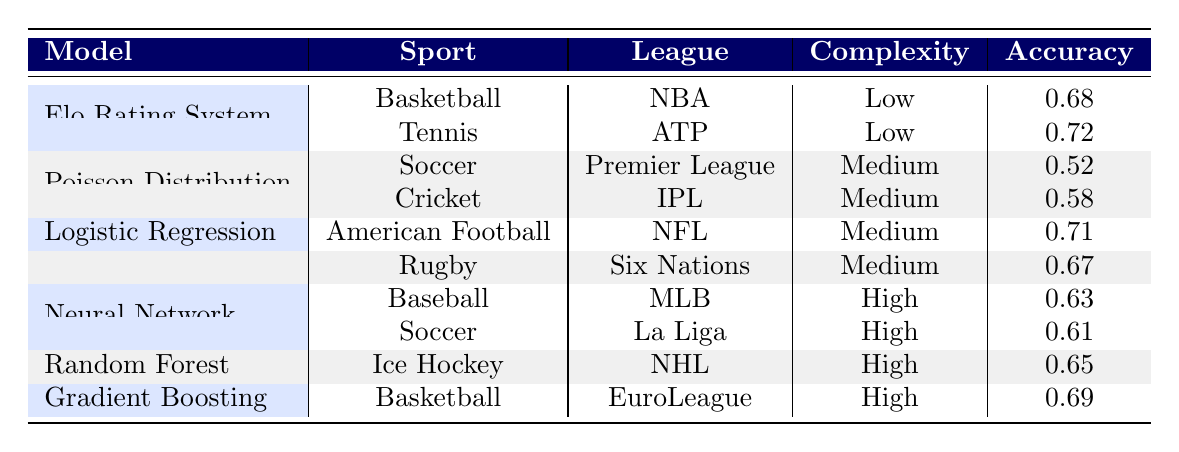What is the accuracy of the Elo Rating System in Tennis for the 2021 season? The table shows that the accuracy for the Elo Rating System in Tennis during the 2021 season is 0.72.
Answer: 0.72 Which model has the highest accuracy in the dataset? Elo Rating System in Tennis has the highest accuracy of 0.72 compared to all other models listed.
Answer: Elo Rating System How many models have a low complexity? The table indicates that there are 2 models (Elo Rating System for Basketball and Tennis) classified with low complexity.
Answer: 2 What is the average accuracy of the models used in American Football and Rugby? The accuracy for Logistic Regression in American Football is 0.71, and for Rugby it is 0.67. The average accuracy is (0.71 + 0.67) / 2 = 0.69.
Answer: 0.69 Is the accuracy of the Random Forest model greater than 0.70? The accuracy for the Random Forest model is 0.65, which is less than 0.70.
Answer: No What is the difference in accuracy between the Poisson Distribution model in Soccer and Cricket? The accuracy for Poisson Distribution in Soccer is 0.52 and in Cricket is 0.58. The difference is 0.58 - 0.52 = 0.06.
Answer: 0.06 Which sport has the Neural Network model with the highest accuracy? The Neural Network model's accuracy in Baseball is 0.63, whereas in Soccer it is 0.61. Therefore, Baseball has the highest accuracy for the Neural Network model.
Answer: Baseball How many models are categorized as high complexity? The table shows there are 4 models (Neural Network in Baseball and Soccer, Random Forest in Ice Hockey, and Gradient Boosting in Basketball) classified as high complexity.
Answer: 4 What is the sample size for the Poisson Distribution model in Cricket? The table indicates that the sample size for the Poisson Distribution model in Cricket is 60.
Answer: 60 